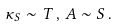Convert formula to latex. <formula><loc_0><loc_0><loc_500><loc_500>\kappa _ { S } \sim T \, , \, A \sim S \, .</formula> 